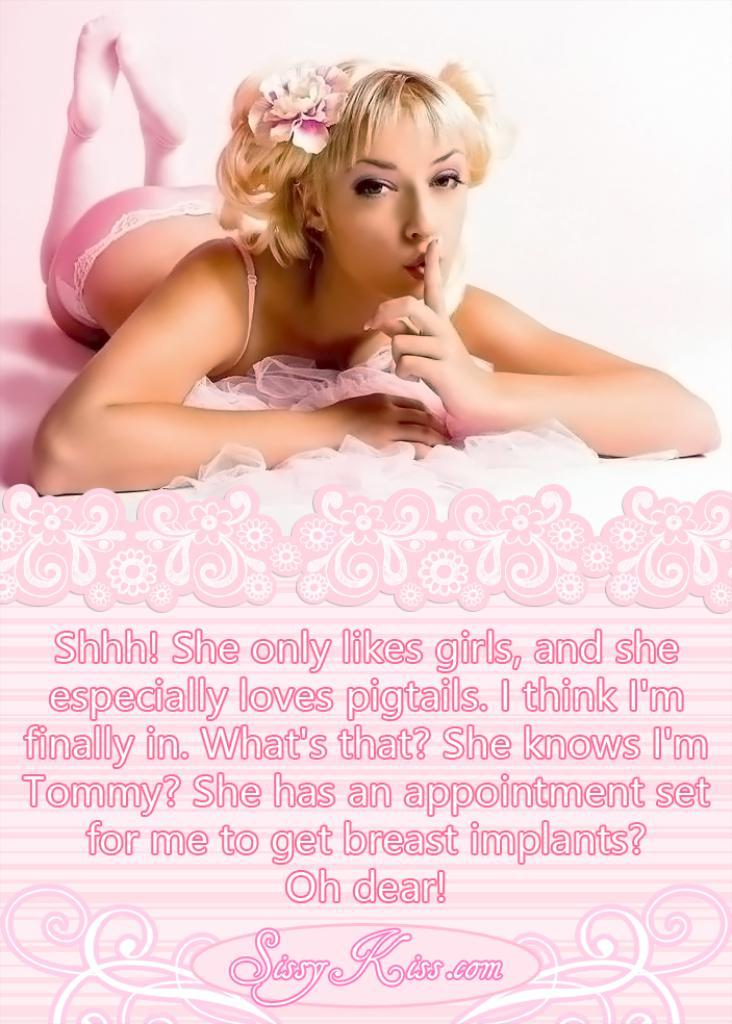Who is the main subject in the image? There is a woman in the image. What is the woman doing in the image? The woman is lying on a surface. What else can be seen in the image besides the woman? There is text or writing visible in the image. What type of vase is the woman holding in the image? There is no vase present in the image; the woman is lying on a surface and there is text or writing visible. 